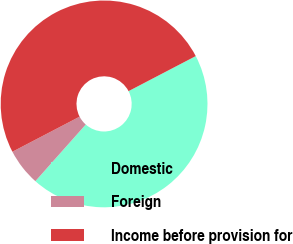Convert chart. <chart><loc_0><loc_0><loc_500><loc_500><pie_chart><fcel>Domestic<fcel>Foreign<fcel>Income before provision for<nl><fcel>44.22%<fcel>5.78%<fcel>50.0%<nl></chart> 